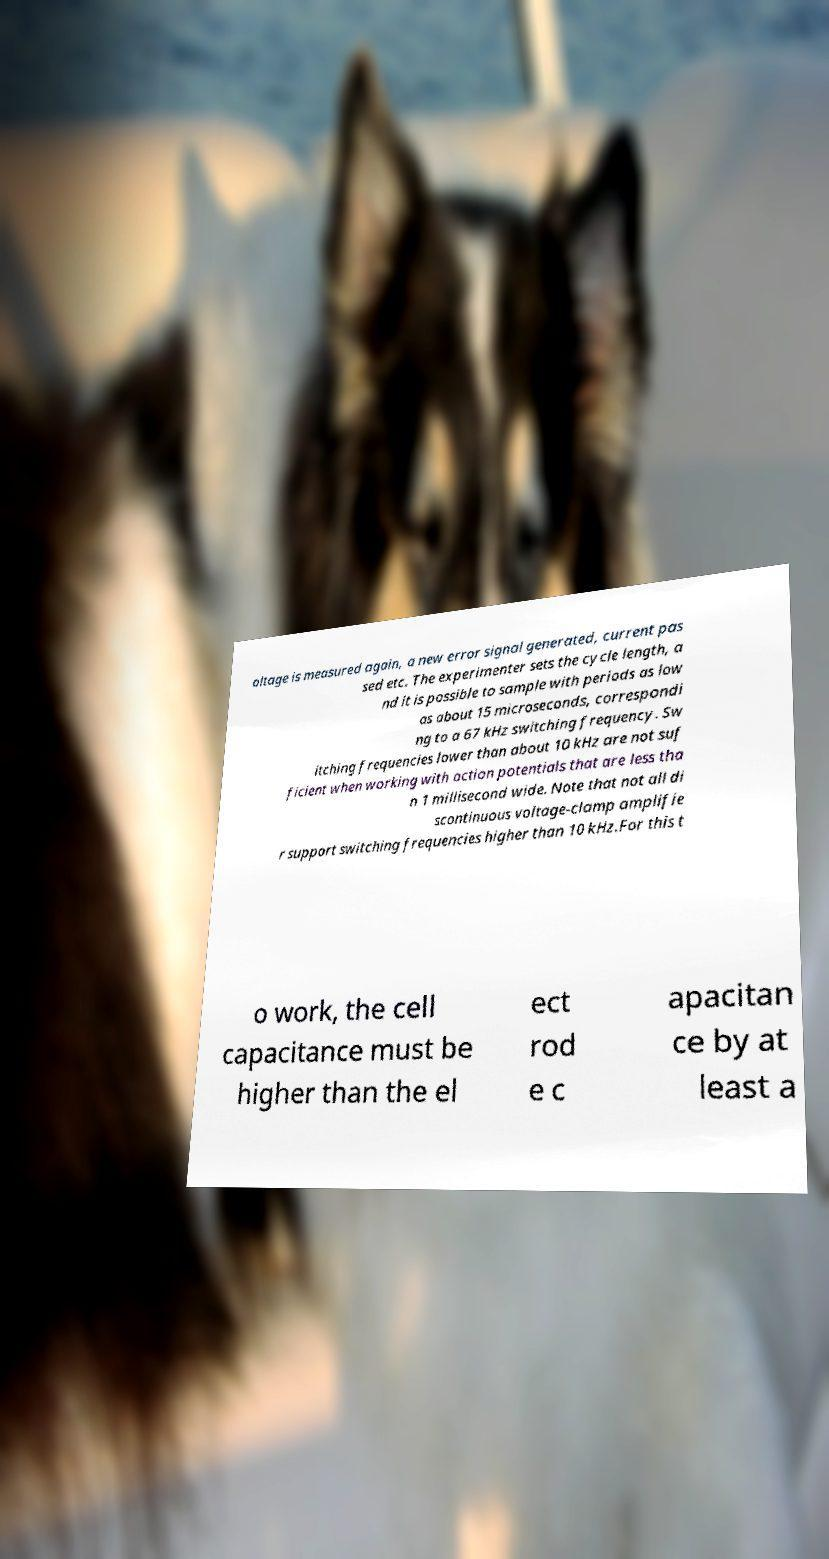What messages or text are displayed in this image? I need them in a readable, typed format. oltage is measured again, a new error signal generated, current pas sed etc. The experimenter sets the cycle length, a nd it is possible to sample with periods as low as about 15 microseconds, correspondi ng to a 67 kHz switching frequency. Sw itching frequencies lower than about 10 kHz are not suf ficient when working with action potentials that are less tha n 1 millisecond wide. Note that not all di scontinuous voltage-clamp amplifie r support switching frequencies higher than 10 kHz.For this t o work, the cell capacitance must be higher than the el ect rod e c apacitan ce by at least a 